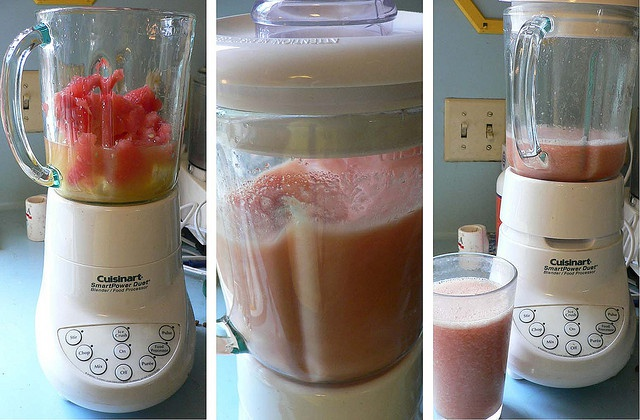Describe the objects in this image and their specific colors. I can see a cup in gray, lightgray, brown, and darkgray tones in this image. 